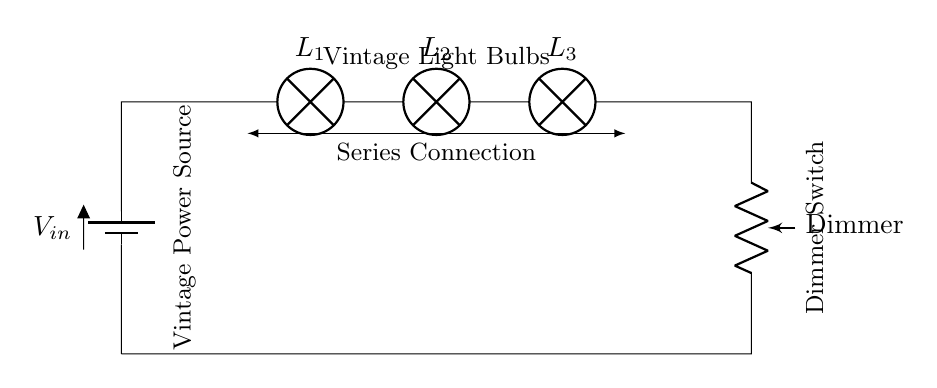What type of circuit is represented? The circuit is a series circuit because all components are connected end-to-end in a single path, leading to something known as a series connection.
Answer: series circuit How many light bulbs are there? The circuit diagram displays three light bulbs connected in series as indicated by the labels on the components.
Answer: three What is the purpose of the dimmer switch? The dimmer switch serves to adjust the brightness of the connected light bulbs by varying the resistance within the circuit; it regulates the current flowing through the bulbs.
Answer: adjust brightness What happens to the brightness of the bulbs when the dimmer switch is decreased? When the dimmer switch is decreased, the resistance increases, which in turn reduces the current flowing through the circuit, causing the bulbs to dim.
Answer: bulbs dim What is connected to the input voltage source? The input voltage source is connected to the light bulbs and the dimmer switch in a sequence, supplying power to the entire circuit.
Answer: light bulbs and dimmer switch What would happen if one light bulb fails in this circuit? If one light bulb fails, the circuit will break and all bulbs will turn off because in a series circuit, the current must pass through each component sequentially.
Answer: all bulbs go off How is the connection type demonstrated in this circuit? The connection type is demonstrated through the use of a straight line connecting each component, indicating that they belong to a single pathway for current flow.
Answer: series connection 